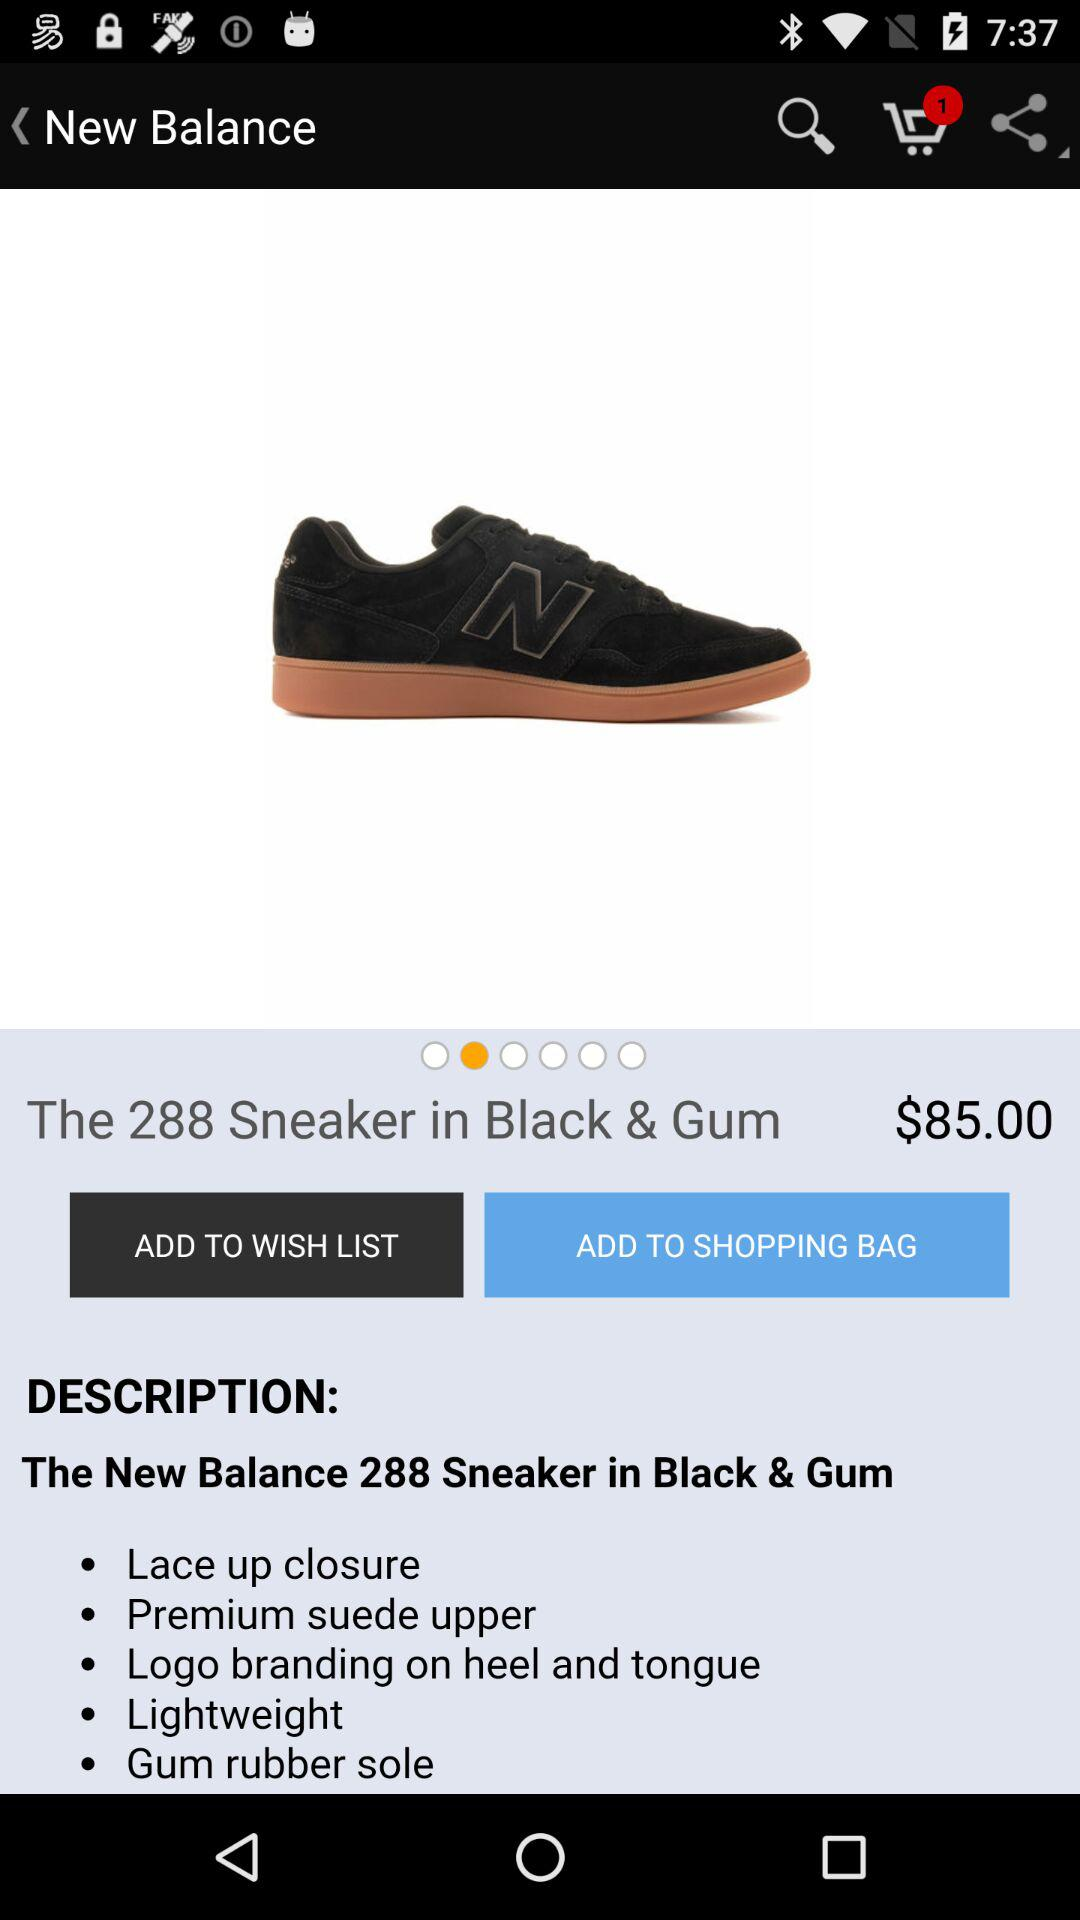What is the name of the product? The name of the product is "The 288 Sneaker in Black & Gum". 